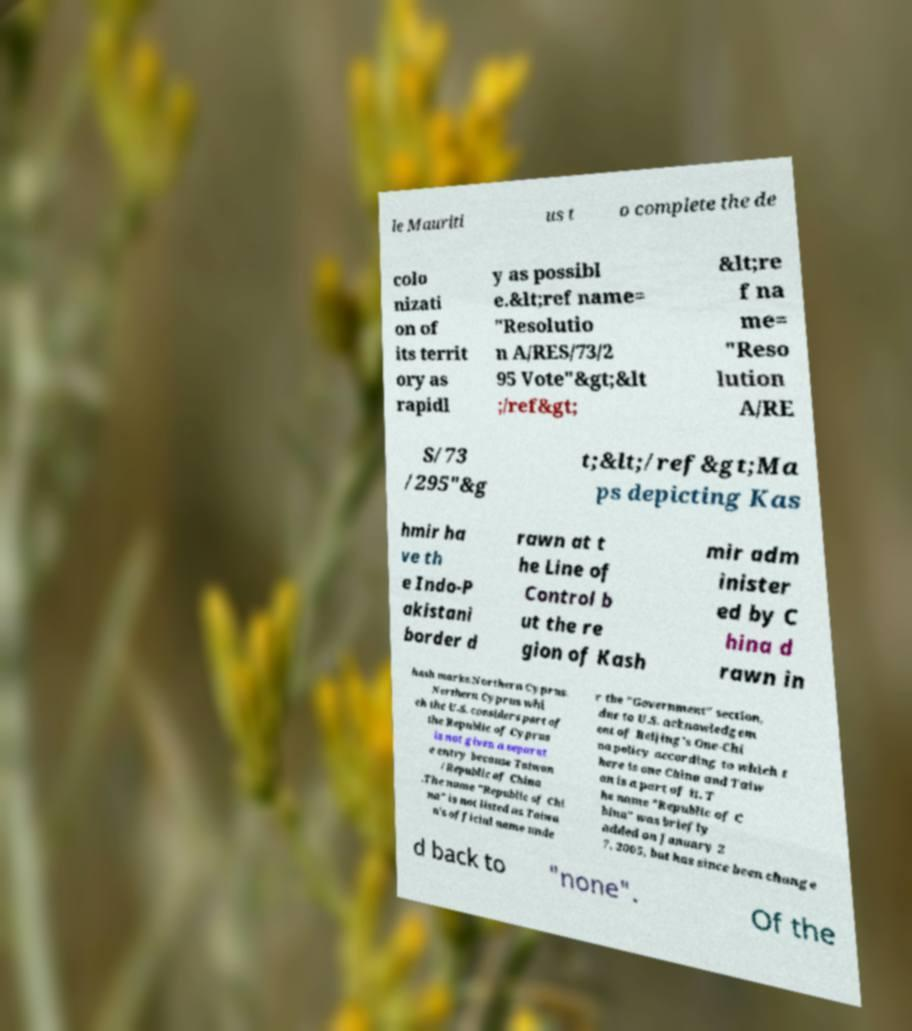Could you assist in decoding the text presented in this image and type it out clearly? le Mauriti us t o complete the de colo nizati on of its territ ory as rapidl y as possibl e.&lt;ref name= "Resolutio n A/RES/73/2 95 Vote"&gt;&lt ;/ref&gt; &lt;re f na me= "Reso lution A/RE S/73 /295"&g t;&lt;/ref&gt;Ma ps depicting Kas hmir ha ve th e Indo-P akistani border d rawn at t he Line of Control b ut the re gion of Kash mir adm inister ed by C hina d rawn in hash marks.Northern Cyprus. Northern Cyprus whi ch the U.S. considers part of the Republic of Cyprus is not given a separat e entry because Taiwan /Republic of China .The name "Republic of Chi na" is not listed as Taiwa n's official name unde r the "Government" section, due to U.S. acknowledgem ent of Beijing's One-Chi na policy according to which t here is one China and Taiw an is a part of it. T he name "Republic of C hina" was briefly added on January 2 7, 2005, but has since been change d back to "none". Of the 